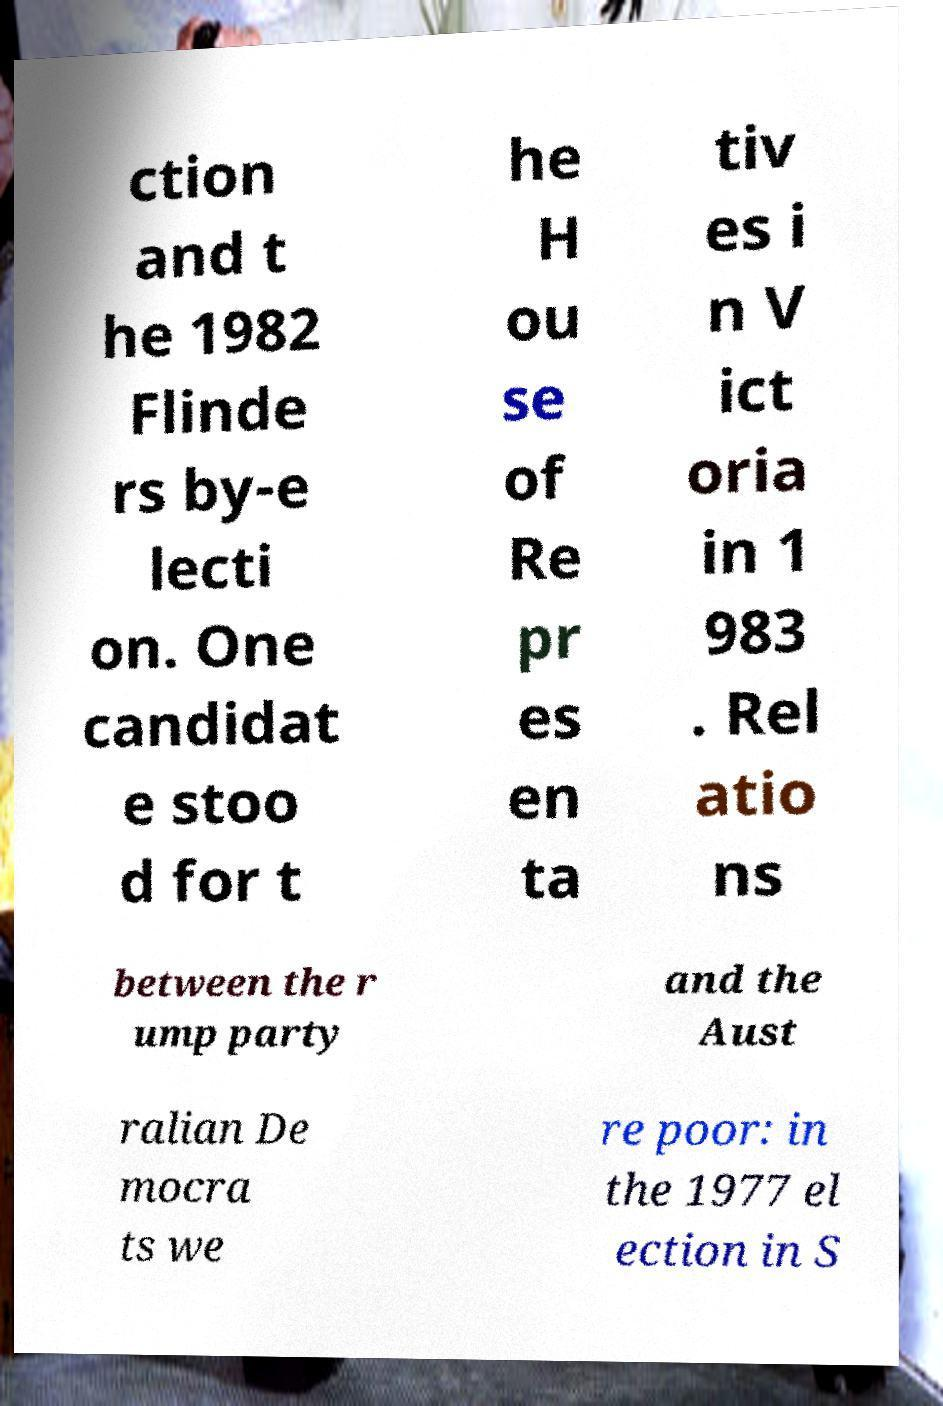What messages or text are displayed in this image? I need them in a readable, typed format. ction and t he 1982 Flinde rs by-e lecti on. One candidat e stoo d for t he H ou se of Re pr es en ta tiv es i n V ict oria in 1 983 . Rel atio ns between the r ump party and the Aust ralian De mocra ts we re poor: in the 1977 el ection in S 